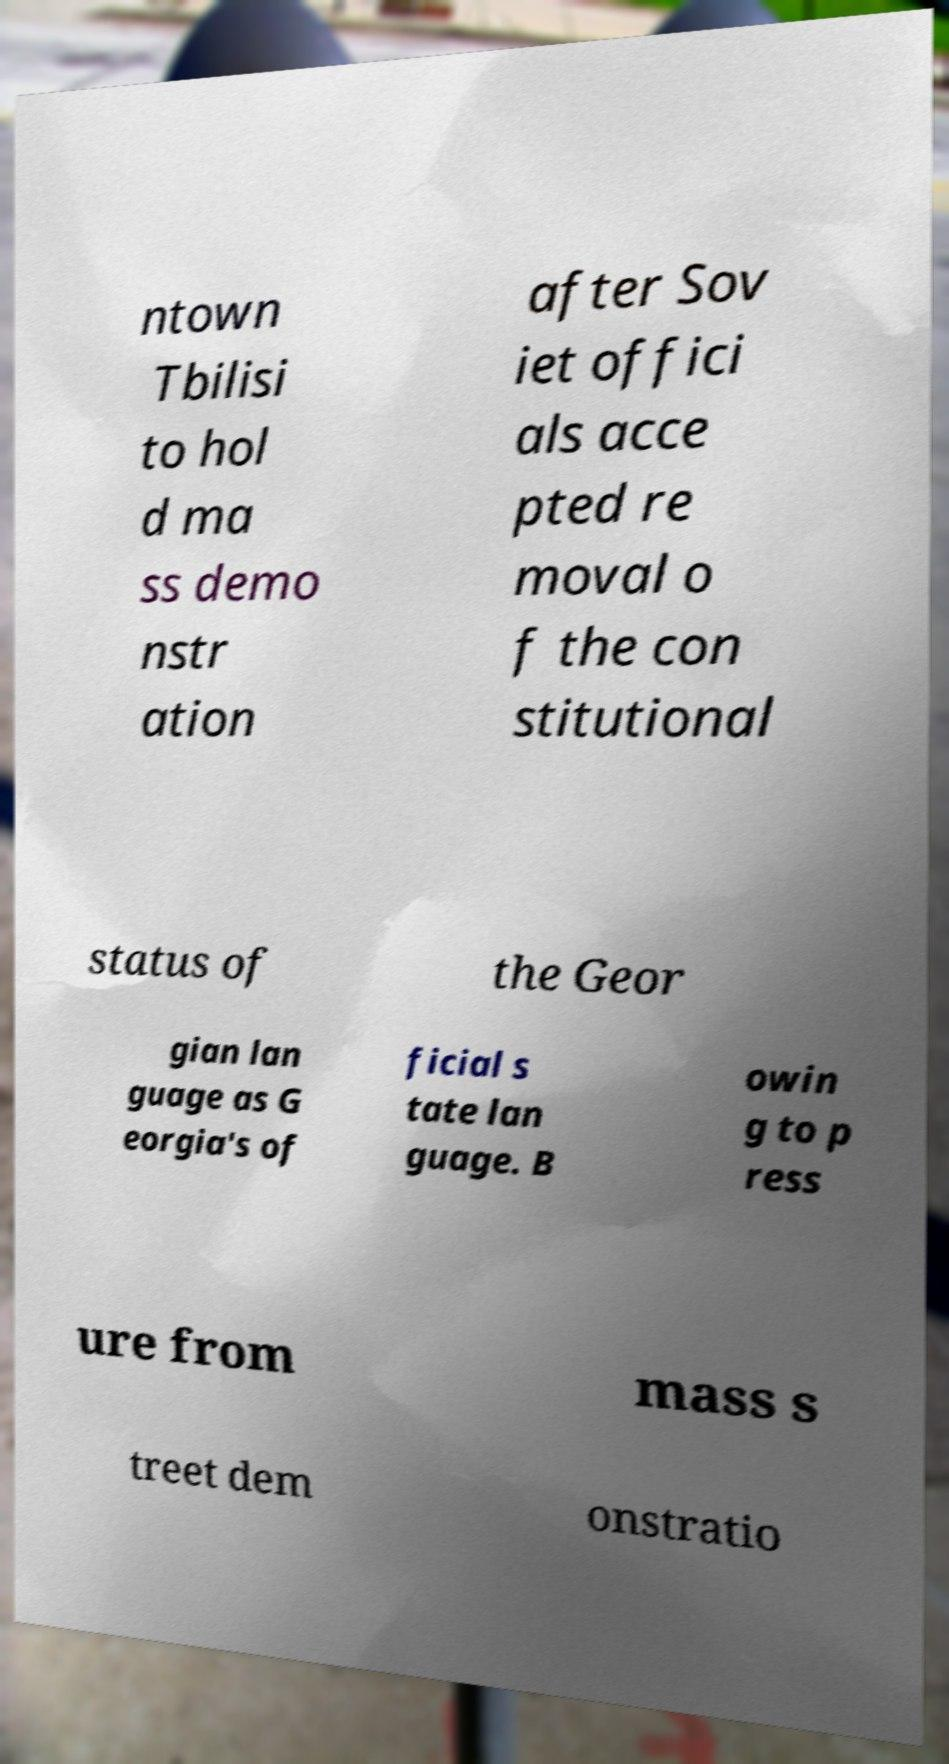Can you accurately transcribe the text from the provided image for me? ntown Tbilisi to hol d ma ss demo nstr ation after Sov iet offici als acce pted re moval o f the con stitutional status of the Geor gian lan guage as G eorgia's of ficial s tate lan guage. B owin g to p ress ure from mass s treet dem onstratio 